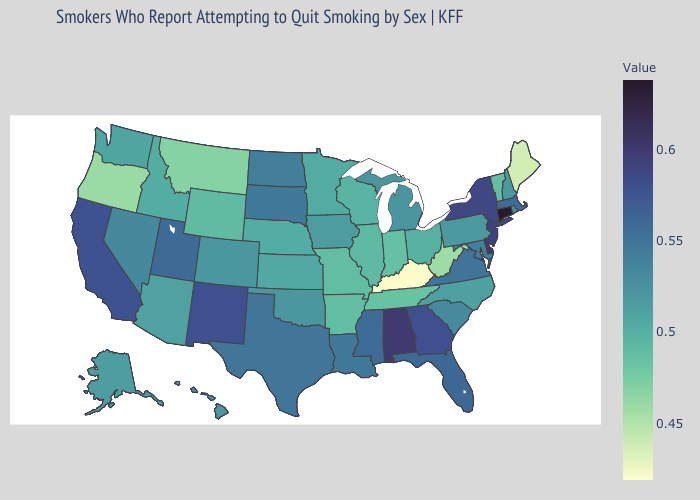Which states have the highest value in the USA?
Quick response, please. Connecticut. Among the states that border Illinois , does Indiana have the lowest value?
Short answer required. No. Among the states that border Delaware , does New Jersey have the highest value?
Give a very brief answer. Yes. Among the states that border Vermont , which have the lowest value?
Quick response, please. New Hampshire. 